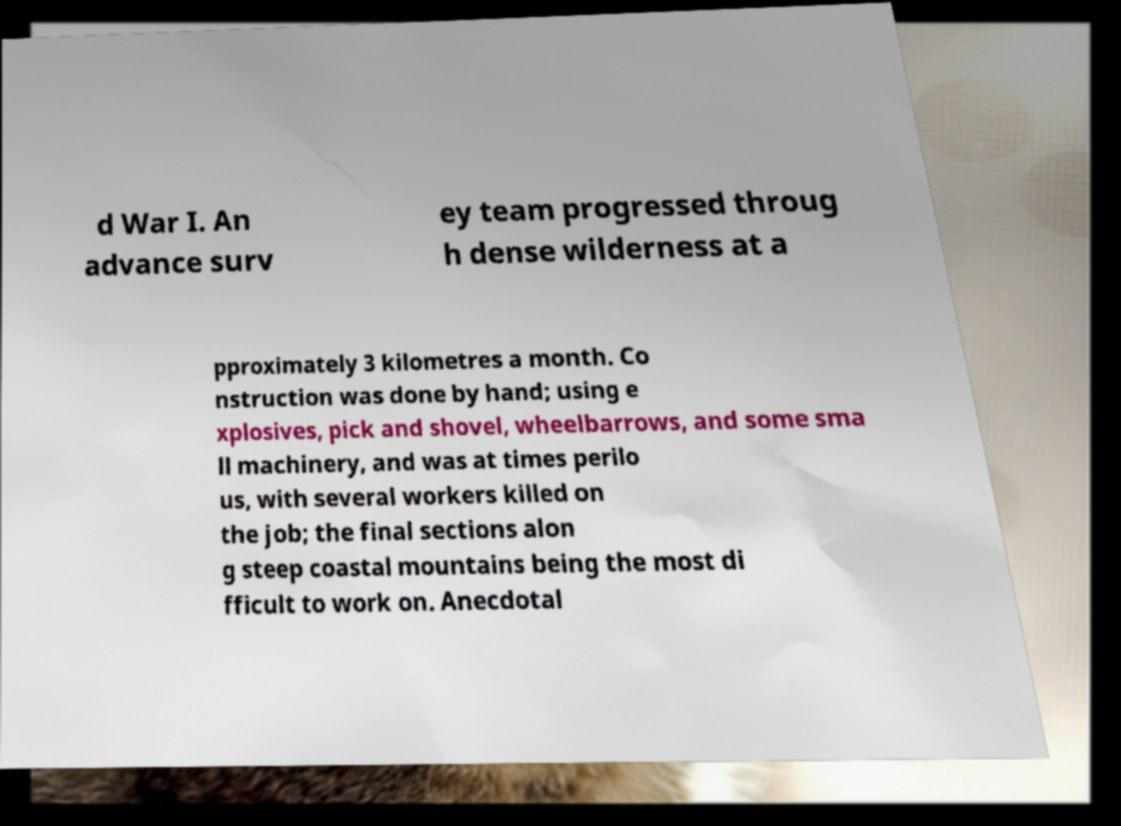Please read and relay the text visible in this image. What does it say? d War I. An advance surv ey team progressed throug h dense wilderness at a pproximately 3 kilometres a month. Co nstruction was done by hand; using e xplosives, pick and shovel, wheelbarrows, and some sma ll machinery, and was at times perilo us, with several workers killed on the job; the final sections alon g steep coastal mountains being the most di fficult to work on. Anecdotal 